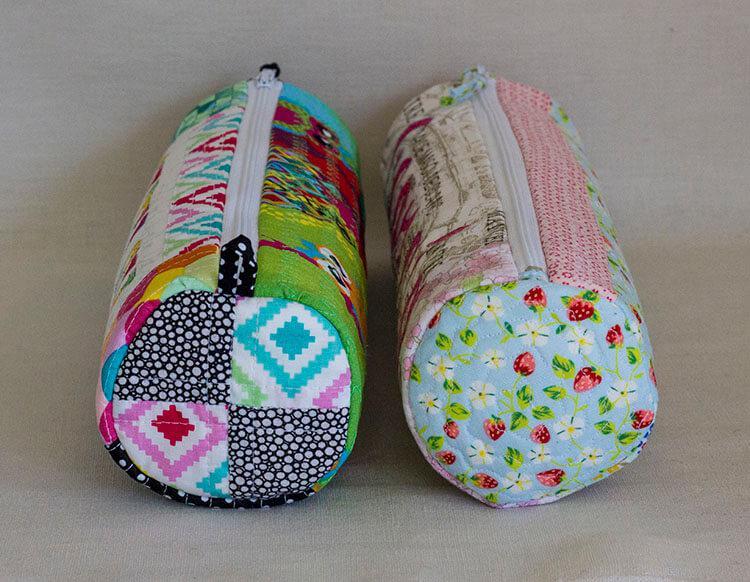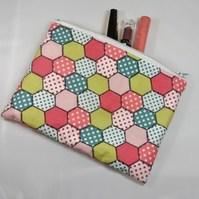The first image is the image on the left, the second image is the image on the right. Evaluate the accuracy of this statement regarding the images: "One image shows two tube-shaped zipper cases with patchwork patterns displayed end-first, and the other image shows one flat zipper case with a patterned exterior.". Is it true? Answer yes or no. Yes. The first image is the image on the left, the second image is the image on the right. For the images shown, is this caption "Exactly one pouch is open with office supplies sticking out." true? Answer yes or no. Yes. 